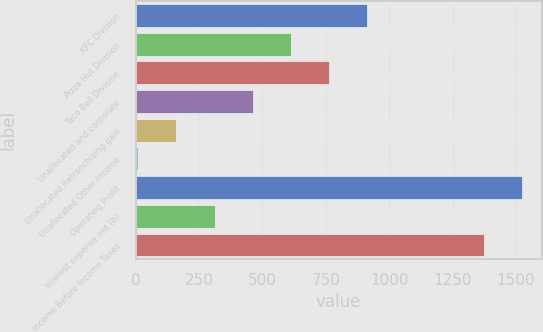<chart> <loc_0><loc_0><loc_500><loc_500><bar_chart><fcel>KFC Division<fcel>Pizza Hut Division<fcel>Taco Bell Division<fcel>Unallocated and corporate<fcel>Unallocated Refranchising gain<fcel>Unallocated Other income<fcel>Operating Profit<fcel>Interest expense net (b)<fcel>Income Before Income Taxes<nl><fcel>914.2<fcel>612.8<fcel>763.5<fcel>462.1<fcel>160.7<fcel>10<fcel>1524.7<fcel>311.4<fcel>1374<nl></chart> 